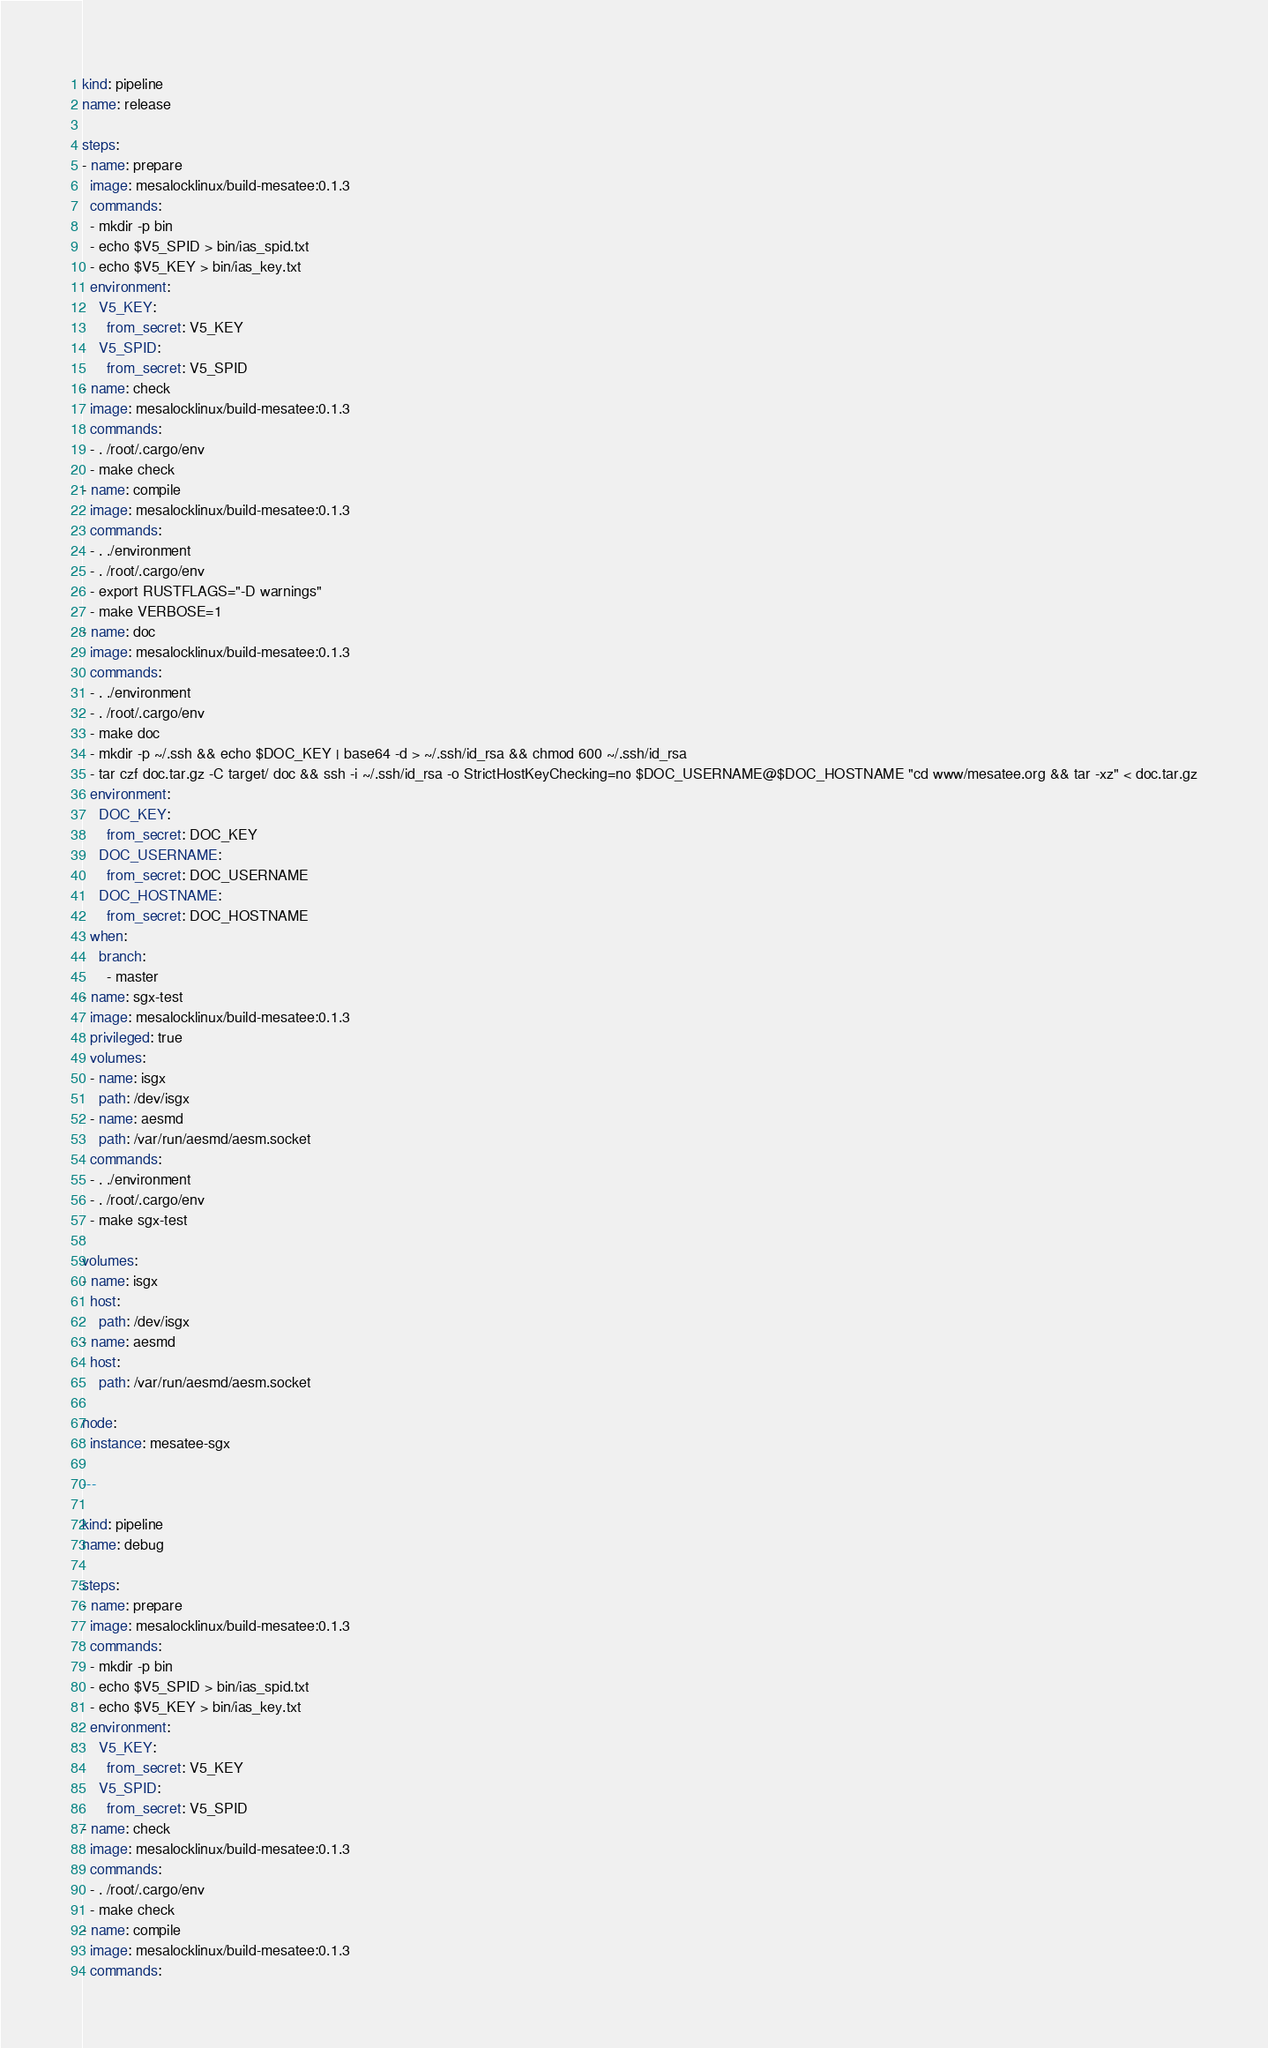Convert code to text. <code><loc_0><loc_0><loc_500><loc_500><_YAML_>kind: pipeline
name: release

steps:
- name: prepare
  image: mesalocklinux/build-mesatee:0.1.3
  commands:
  - mkdir -p bin
  - echo $V5_SPID > bin/ias_spid.txt
  - echo $V5_KEY > bin/ias_key.txt
  environment:
    V5_KEY:
      from_secret: V5_KEY
    V5_SPID:
      from_secret: V5_SPID
- name: check
  image: mesalocklinux/build-mesatee:0.1.3
  commands:
  - . /root/.cargo/env
  - make check
- name: compile
  image: mesalocklinux/build-mesatee:0.1.3
  commands:
  - . ./environment
  - . /root/.cargo/env
  - export RUSTFLAGS="-D warnings"
  - make VERBOSE=1
- name: doc
  image: mesalocklinux/build-mesatee:0.1.3
  commands:
  - . ./environment
  - . /root/.cargo/env
  - make doc
  - mkdir -p ~/.ssh && echo $DOC_KEY | base64 -d > ~/.ssh/id_rsa && chmod 600 ~/.ssh/id_rsa
  - tar czf doc.tar.gz -C target/ doc && ssh -i ~/.ssh/id_rsa -o StrictHostKeyChecking=no $DOC_USERNAME@$DOC_HOSTNAME "cd www/mesatee.org && tar -xz" < doc.tar.gz
  environment:
    DOC_KEY:
      from_secret: DOC_KEY
    DOC_USERNAME:
      from_secret: DOC_USERNAME
    DOC_HOSTNAME:
      from_secret: DOC_HOSTNAME
  when:
    branch:
      - master
- name: sgx-test
  image: mesalocklinux/build-mesatee:0.1.3
  privileged: true
  volumes:
  - name: isgx
    path: /dev/isgx
  - name: aesmd
    path: /var/run/aesmd/aesm.socket
  commands:
  - . ./environment
  - . /root/.cargo/env
  - make sgx-test

volumes:
- name: isgx
  host:
    path: /dev/isgx
- name: aesmd
  host:
    path: /var/run/aesmd/aesm.socket

node:
  instance: mesatee-sgx

---

kind: pipeline
name: debug

steps:
- name: prepare
  image: mesalocklinux/build-mesatee:0.1.3
  commands:
  - mkdir -p bin
  - echo $V5_SPID > bin/ias_spid.txt
  - echo $V5_KEY > bin/ias_key.txt
  environment:
    V5_KEY:
      from_secret: V5_KEY
    V5_SPID:
      from_secret: V5_SPID
- name: check
  image: mesalocklinux/build-mesatee:0.1.3
  commands:
  - . /root/.cargo/env
  - make check
- name: compile
  image: mesalocklinux/build-mesatee:0.1.3
  commands:</code> 